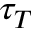<formula> <loc_0><loc_0><loc_500><loc_500>\tau _ { T }</formula> 